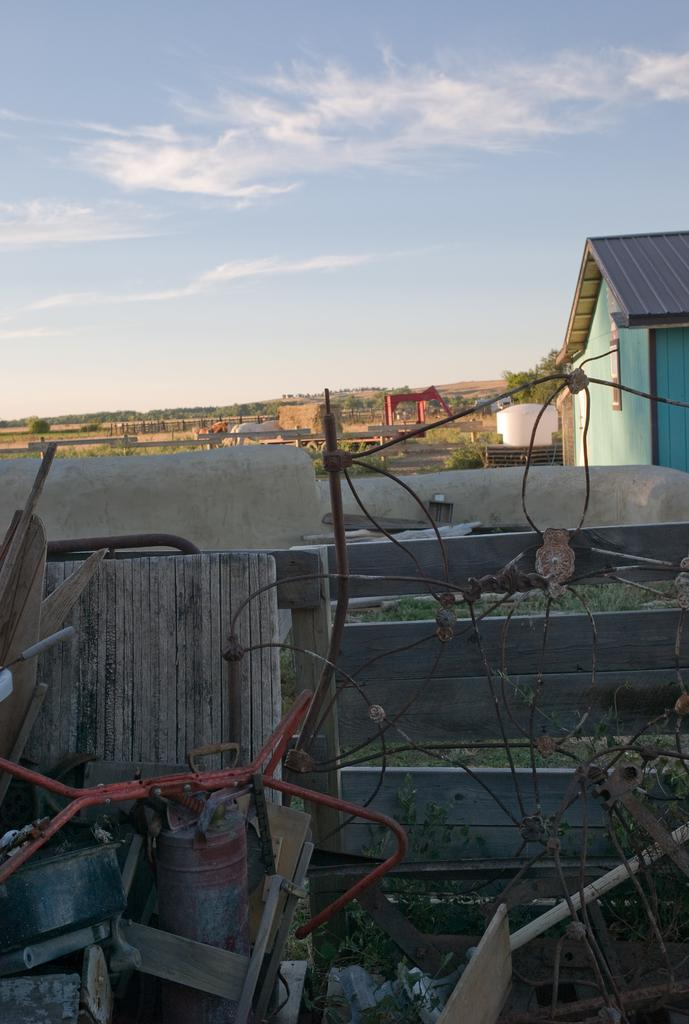What type of material is the wire in the image made of? The wire in the image is made of iron. What kind of objects are made of wood in the image? There are wooden objects and a wooden fence in the image. Where is the house located in relation to the wooden fence? The house is beside the wooden fence. What type of vegetation can be seen in the image? There is grass and trees in the image. What type of landscape feature is visible in the image? There are hills in the image. What is visible in the sky in the image? The sky is visible, and there are clouds in the image. Can you tell me how many clams are sitting on the wooden fence in the image? There are no clams present in the image; it features an iron wire, wooden objects, a wooden fence, a house, grass, trees, hills, and a sky with clouds. What type of drink is being served by the fireman in the image? There is no fireman or drink present in the image. 